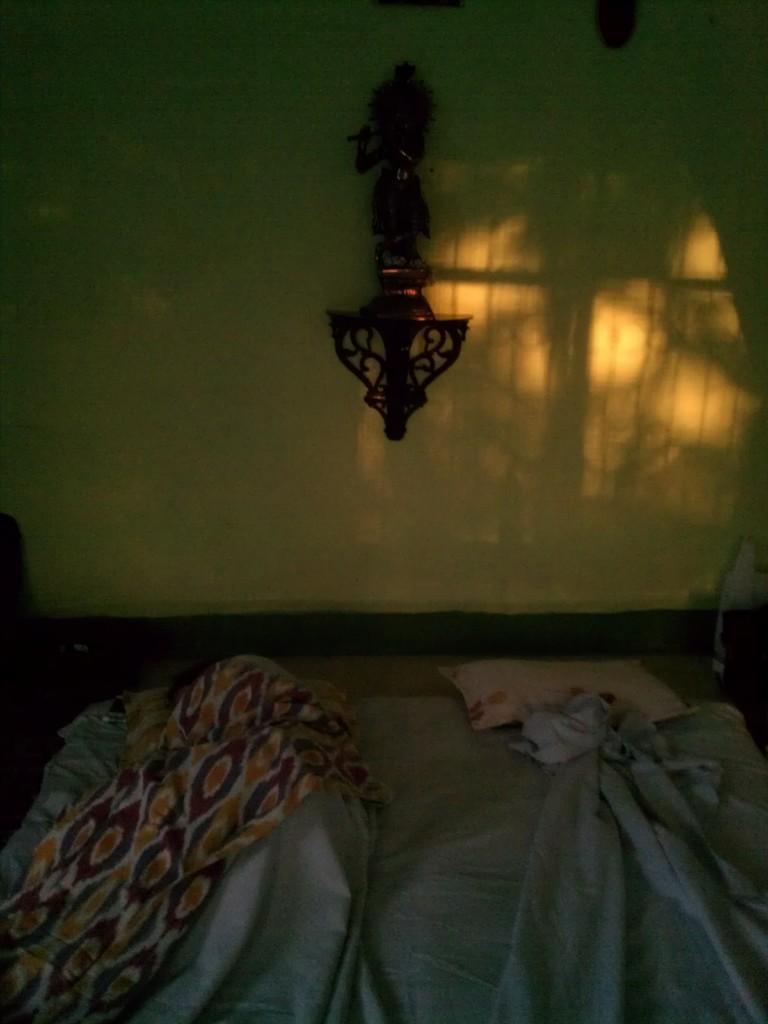In one or two sentences, can you explain what this image depicts? In this picture I can see pillows and blankets. I can see the object on the wall. 